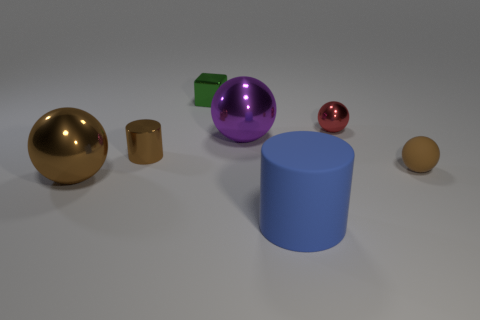Are there an equal number of big metallic spheres behind the purple ball and red spheres?
Your answer should be very brief. No. What number of tiny red metallic objects are the same shape as the big purple thing?
Make the answer very short. 1. Is the tiny brown shiny thing the same shape as the green metal object?
Give a very brief answer. No. How many things are metallic things behind the small red shiny sphere or metal spheres?
Your answer should be very brief. 4. The brown thing that is in front of the brown sphere to the right of the brown sphere that is left of the big blue cylinder is what shape?
Your answer should be very brief. Sphere. There is a small brown object that is the same material as the cube; what shape is it?
Your answer should be compact. Cylinder. The purple ball is what size?
Your response must be concise. Large. Does the brown matte object have the same size as the red metal sphere?
Make the answer very short. Yes. What number of objects are small brown things to the left of the small matte object or small brown things that are in front of the small brown metal thing?
Ensure brevity in your answer.  2. What number of tiny brown matte spheres are on the left side of the cylinder in front of the brown metallic object in front of the tiny cylinder?
Your answer should be very brief. 0. 